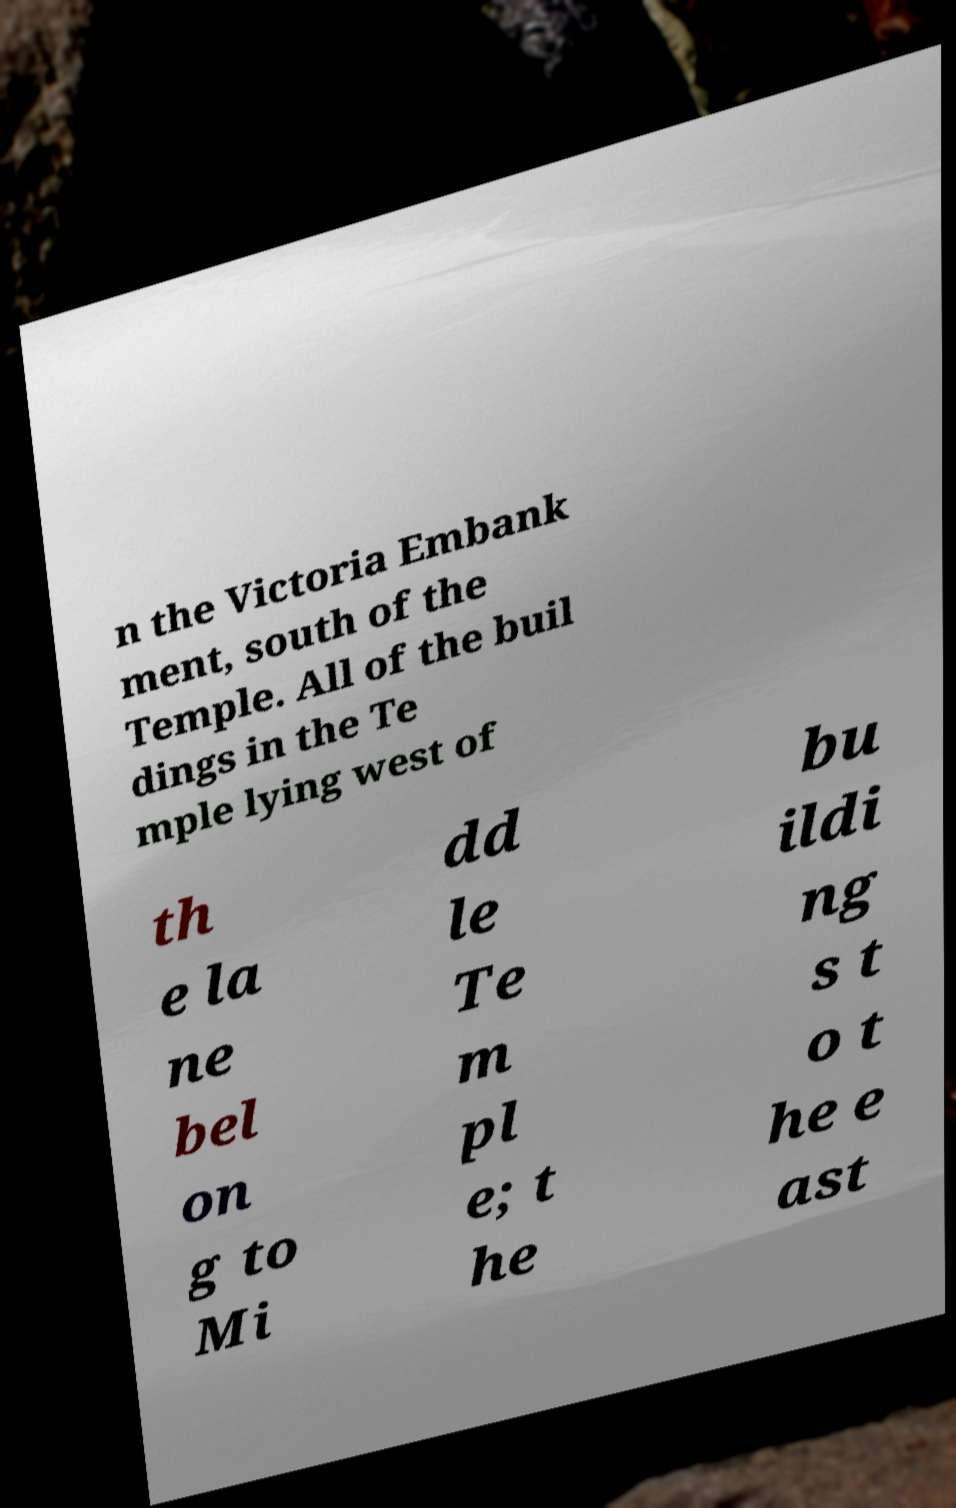Can you read and provide the text displayed in the image?This photo seems to have some interesting text. Can you extract and type it out for me? n the Victoria Embank ment, south of the Temple. All of the buil dings in the Te mple lying west of th e la ne bel on g to Mi dd le Te m pl e; t he bu ildi ng s t o t he e ast 